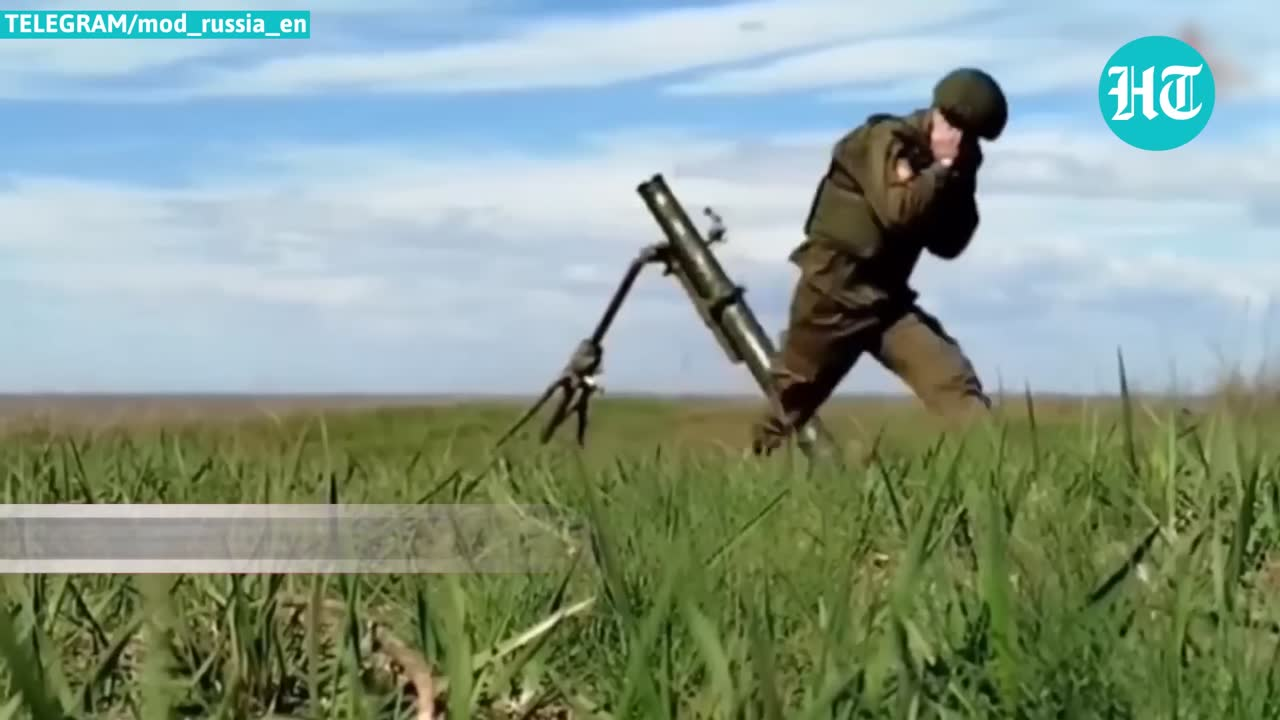describe the img, focus on action and behave The image shows a soldier in camouflage clothing firing a mortar. He is crouching low to the ground, focusing on the target. The mortar is mounted on a tripod, and the soldier is holding the firing mechanism. The background of the image is a field of tall grass. The soldier's actions are focused and determined, and his behavior suggests a sense of urgency and danger. The image is likely a depiction of a real-life combat situation. 